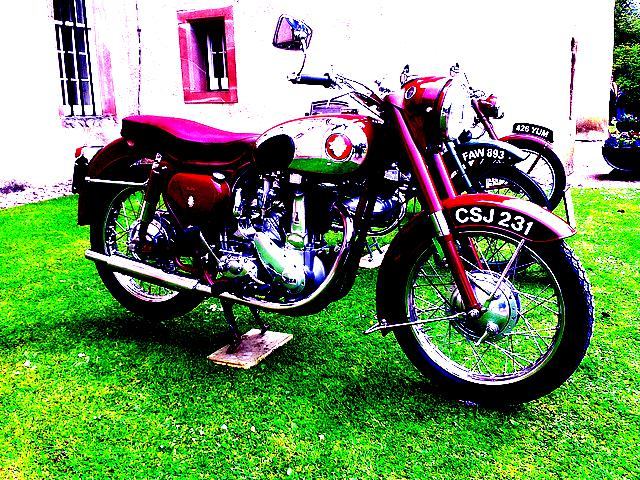What kind of maintenance might a motorcycle like this require? A classic motorcycle of this era would require regular and thorough maintenance to preserve its condition. This includes engine tuning, oil changes, rust protection, and careful preservation of its original parts, which could be harder to replace due to their age and rarity. 